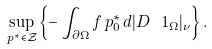Convert formula to latex. <formula><loc_0><loc_0><loc_500><loc_500>\sup _ { p ^ { * } \in \mathcal { Z } } \left \{ - \int _ { \partial \Omega } f \, p _ { 0 } ^ { * } \, d | D \ 1 _ { \Omega } | _ { \nu } \right \} .</formula> 